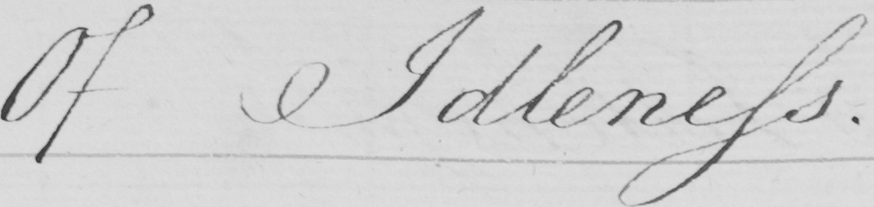Can you tell me what this handwritten text says? Of Idleness . 